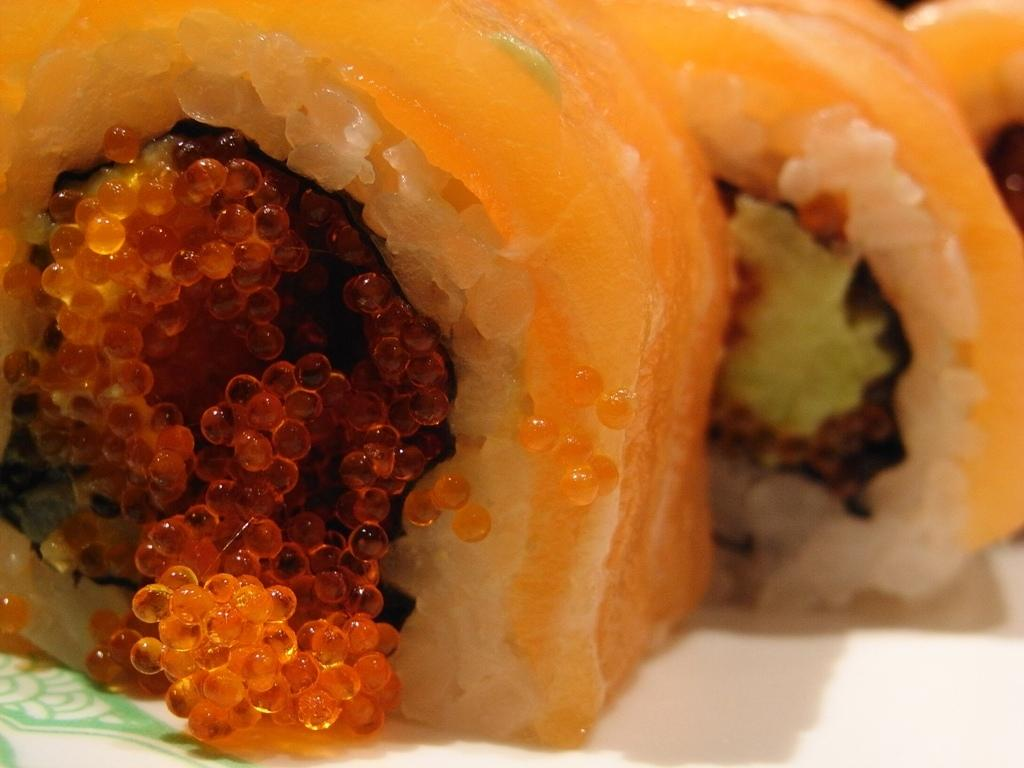What is present in the image? There is food in the image. What is the color of the surface on which the food is placed? The food is on a white surface. How many tomatoes are being offered by the beggar in the image? There is no beggar or tomatoes present in the image. What type of art is displayed on the white surface in the image? There is no art displayed on the white surface in the image; it is occupied by food. 